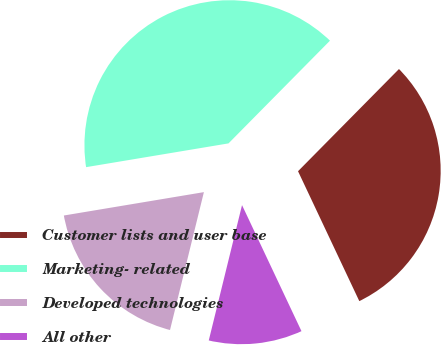Convert chart to OTSL. <chart><loc_0><loc_0><loc_500><loc_500><pie_chart><fcel>Customer lists and user base<fcel>Marketing- related<fcel>Developed technologies<fcel>All other<nl><fcel>30.58%<fcel>40.03%<fcel>18.53%<fcel>10.85%<nl></chart> 